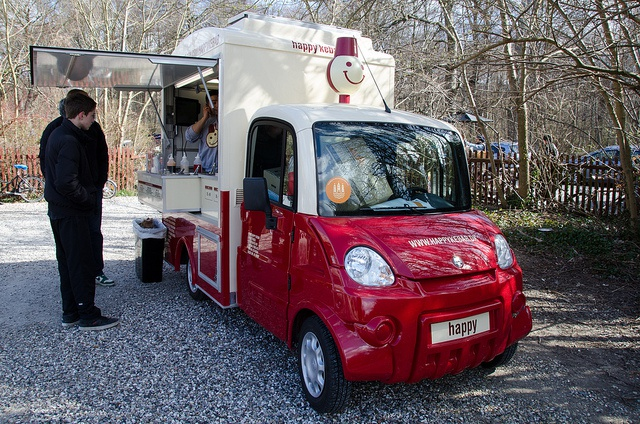Describe the objects in this image and their specific colors. I can see truck in lightgray, maroon, black, and darkgray tones, people in lightgray, black, and gray tones, car in lightgray, black, gray, and blue tones, people in lightgray, black, gray, and navy tones, and bicycle in lightgray, darkgray, gray, black, and brown tones in this image. 